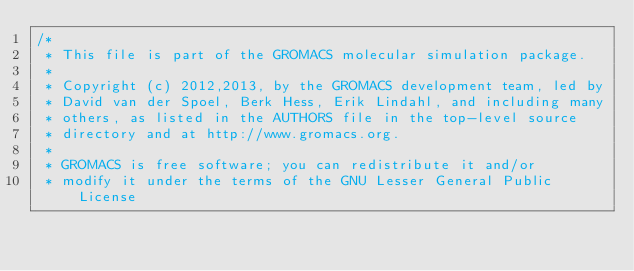Convert code to text. <code><loc_0><loc_0><loc_500><loc_500><_C_>/*
 * This file is part of the GROMACS molecular simulation package.
 *
 * Copyright (c) 2012,2013, by the GROMACS development team, led by
 * David van der Spoel, Berk Hess, Erik Lindahl, and including many
 * others, as listed in the AUTHORS file in the top-level source
 * directory and at http://www.gromacs.org.
 *
 * GROMACS is free software; you can redistribute it and/or
 * modify it under the terms of the GNU Lesser General Public License</code> 